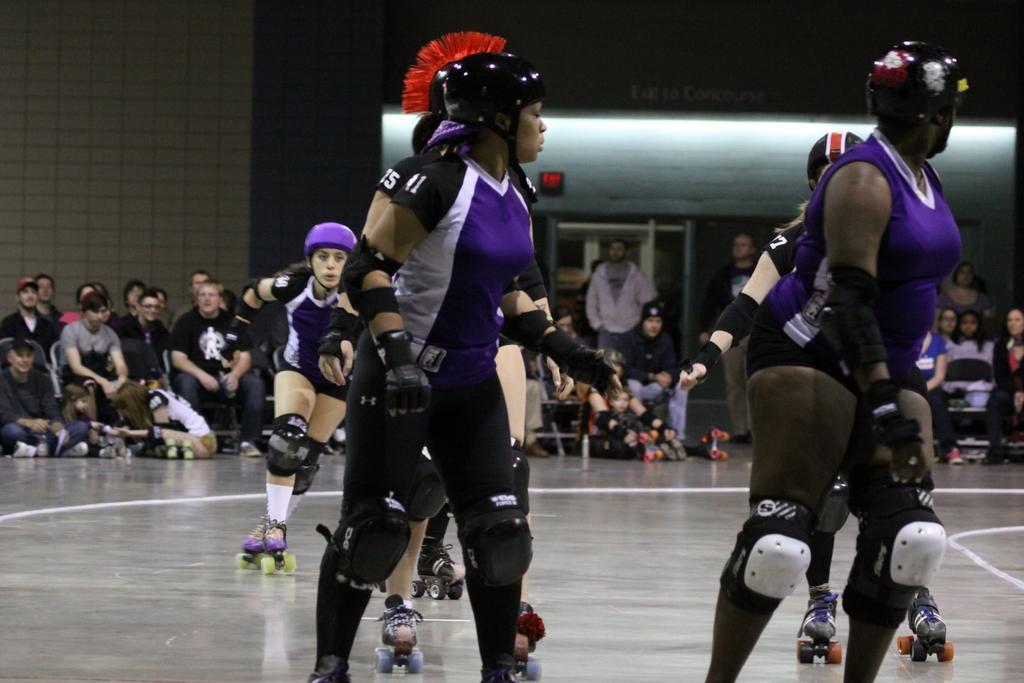In one or two sentences, can you explain what this image depicts? In the image in the center,we can see few people were skating and they were wearing helmet. In the background there is a wall and few people were sitting. 